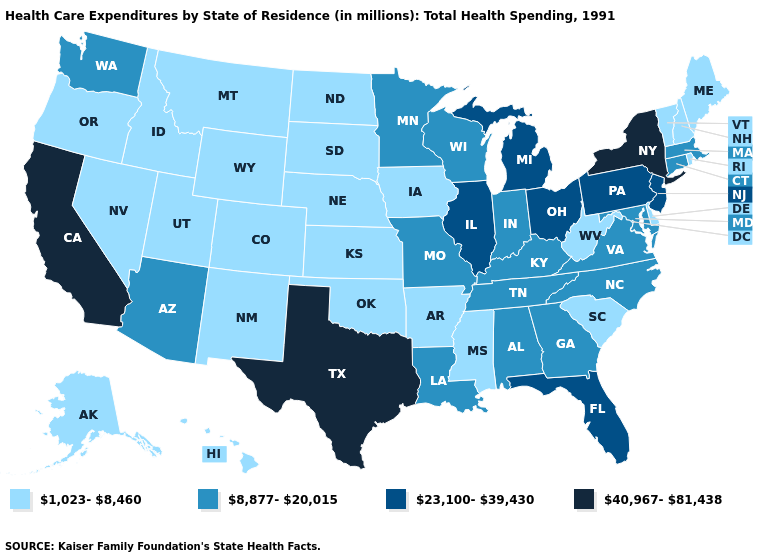Which states have the highest value in the USA?
Be succinct. California, New York, Texas. What is the value of Vermont?
Be succinct. 1,023-8,460. What is the value of Connecticut?
Write a very short answer. 8,877-20,015. Among the states that border Massachusetts , does New York have the highest value?
Give a very brief answer. Yes. What is the highest value in the USA?
Keep it brief. 40,967-81,438. What is the value of New York?
Give a very brief answer. 40,967-81,438. Does Wisconsin have the highest value in the MidWest?
Quick response, please. No. Does California have the highest value in the USA?
Short answer required. Yes. Name the states that have a value in the range 23,100-39,430?
Answer briefly. Florida, Illinois, Michigan, New Jersey, Ohio, Pennsylvania. Among the states that border Oklahoma , which have the lowest value?
Short answer required. Arkansas, Colorado, Kansas, New Mexico. What is the value of Mississippi?
Short answer required. 1,023-8,460. What is the value of Connecticut?
Answer briefly. 8,877-20,015. Among the states that border Oklahoma , which have the lowest value?
Short answer required. Arkansas, Colorado, Kansas, New Mexico. Does Louisiana have the same value as Kentucky?
Short answer required. Yes. What is the value of Oregon?
Give a very brief answer. 1,023-8,460. 